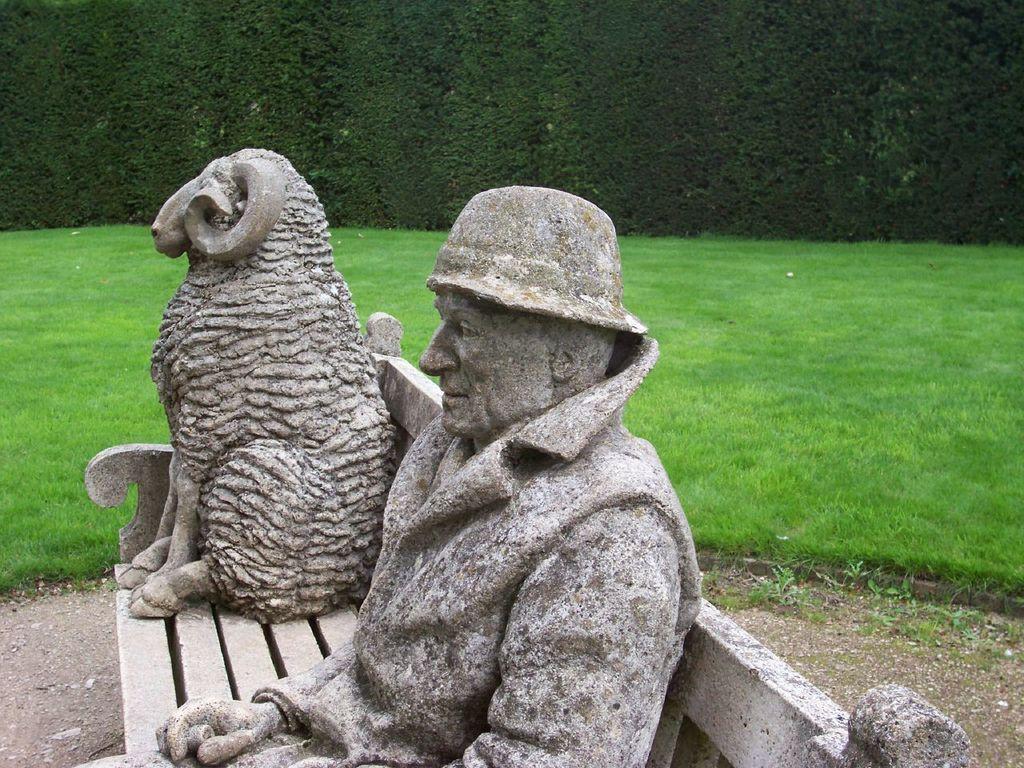Could you give a brief overview of what you see in this image? In this image we can see sculptures on the bench. In the background there is grass and we can see hedge. 